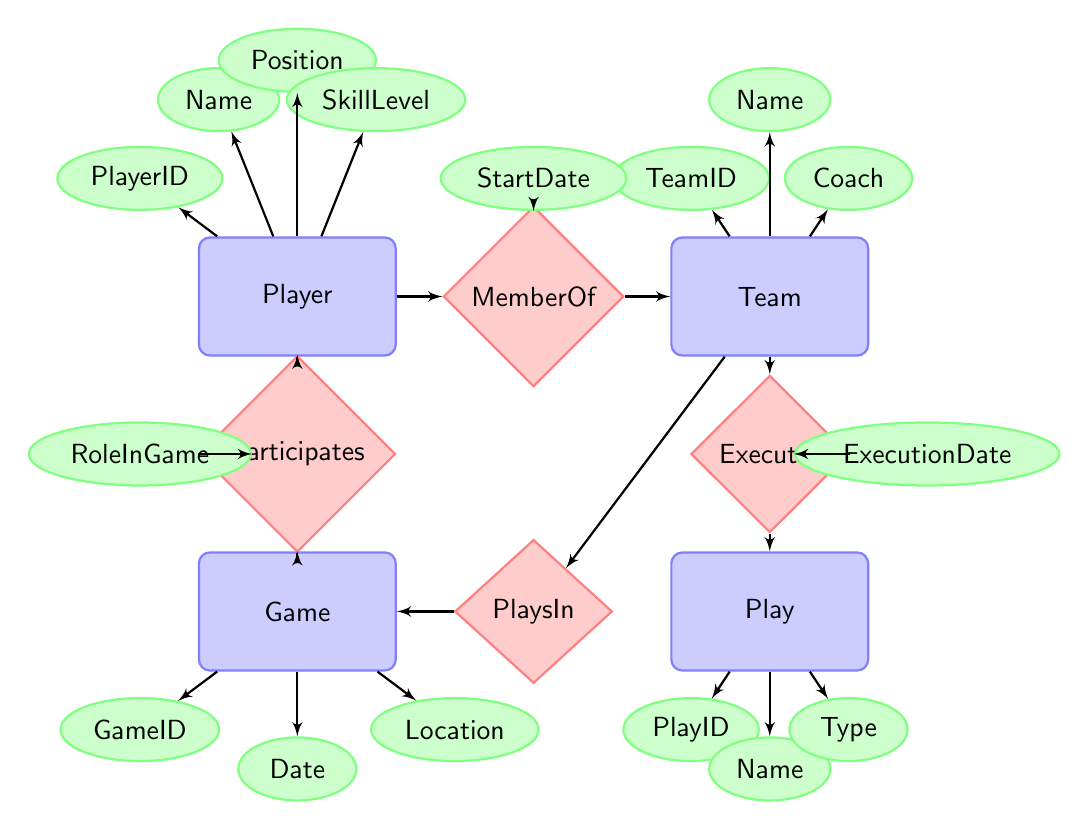What is the primary identifier for a Player? The primary identifier for a Player is represented by the attribute "PlayerID". It is located within the "Player" entity in the diagram.
Answer: PlayerID How many entities are present in the diagram? The diagram contains four entities: Player, Team, Game, and Play. By counting the entity boxes, we can see there are four in total.
Answer: 4 What relationship connects Player and Game? The relationship that connects Player and Game is called "Participates". It is shown as a diamond shape between the Player and Game entities in the diagram.
Answer: Participates What does the attribute "RoleInGame" describe? The attribute "RoleInGame" describes the specific function or position that a player has during a game. This attribute is connected to the "Participates" relationship.
Answer: Specific function or position Which team executes plays in the game? The "Executes" relationship shows that the Team is responsible for executing Plays in games. This relationship connects the Team entity to the Play entity in the diagram.
Answer: Team How are players associated with teams? Players are associated with teams through the "MemberOf" relationship. This relationship links the Player entity with the Team entity, indicating membership.
Answer: MemberOf What feature distinguishes a game event? The feature that distinguishes a game event is the "Location" attribute, which indicates where the game is held. It is part of the Game entity attributes.
Answer: Location When can a team execute a play? A team can execute a play on an "ExecutionDate". This attribute is tied to the "Executes" relationship between Team and Play in the diagram.
Answer: ExecutionDate What is the purpose of the "Type" attribute in the Play entity? The "Type" attribute in the Play entity indicates the kind of play (for example, offensive or defensive) and provides context for the play being executed.
Answer: Indicates the kind of play 